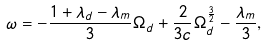<formula> <loc_0><loc_0><loc_500><loc_500>\omega = - \frac { 1 + \lambda _ { d } - \lambda _ { m } } { 3 } \Omega _ { d } + \frac { 2 } { 3 c } \Omega _ { d } ^ { \frac { 3 } { 2 } } - \frac { \lambda _ { m } } { 3 } ,</formula> 